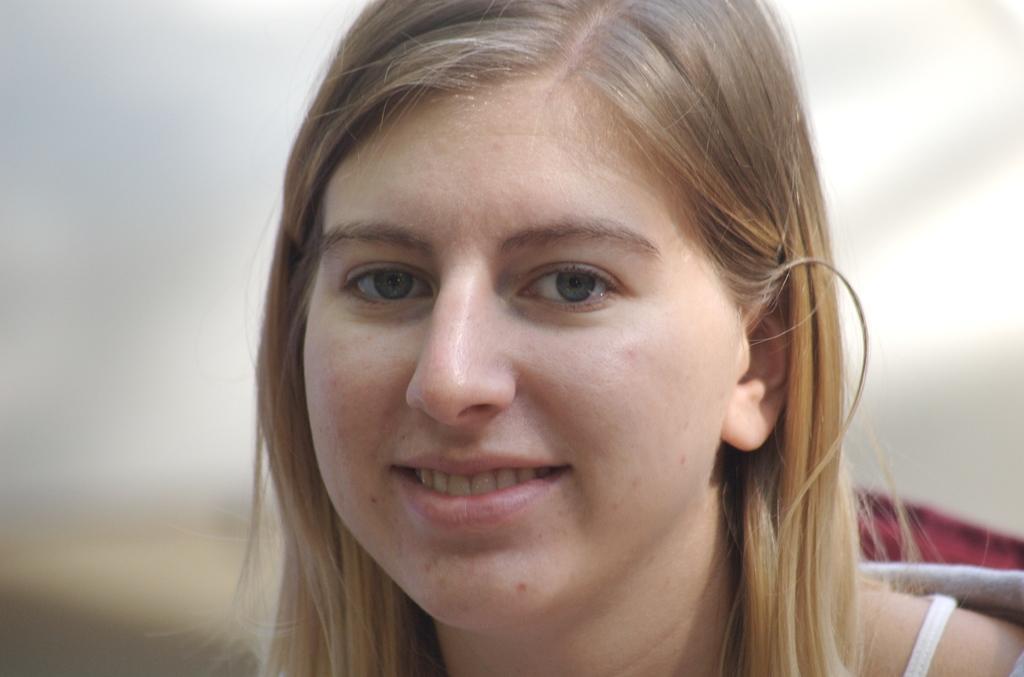In one or two sentences, can you explain what this image depicts? In the center of the image we can see a lady is smiling and wearing a dress. 